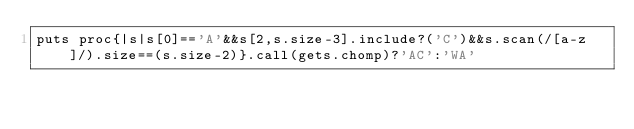Convert code to text. <code><loc_0><loc_0><loc_500><loc_500><_Ruby_>puts proc{|s|s[0]=='A'&&s[2,s.size-3].include?('C')&&s.scan(/[a-z]/).size==(s.size-2)}.call(gets.chomp)?'AC':'WA'
</code> 